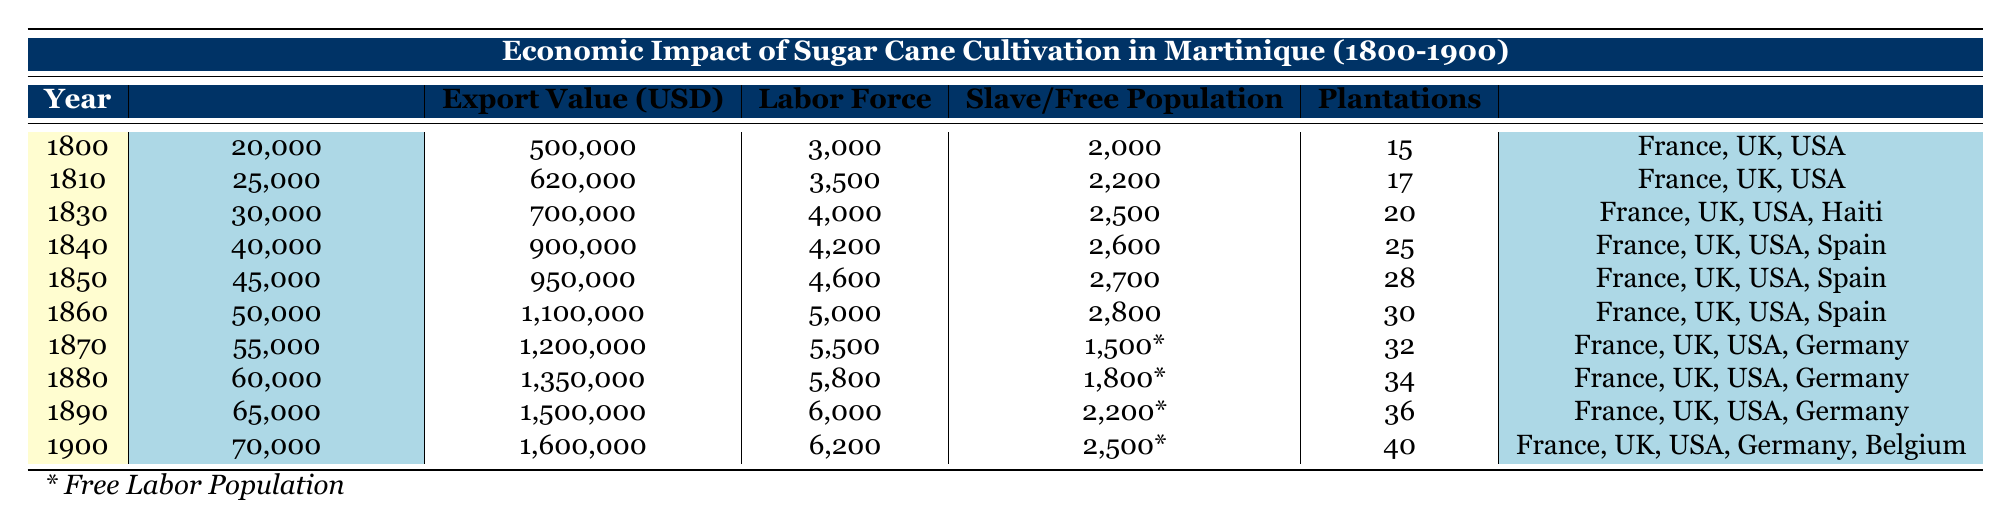What was the sugar cane production in 1860? According to the table, the sugar cane production in 1860 is listed as 50,000 tons.
Answer: 50,000 tons How many plantations were there in 1890? In the table, the number of plantations in 1890 is recorded as 36.
Answer: 36 What is the total export value of sugar cane from 1800 to 1900? To find the total export value, we add the export values for each year: 500,000 + 620,000 + 700,000 + 900,000 + 950,000 + 1,100,000 + 1,200,000 + 1,350,000 + 1,500,000 + 1,600,000 = 10,120,000.
Answer: 10,120,000 USD Was there an increase in the Labor Force from 1810 to 1870? By comparing the Labor Force figures, in 1810 it was 3,500 and in 1870 it was 5,500. This indicates an increase over that period.
Answer: Yes What was the average sugar cane production from 1850 to 1900? To calculate the average production from 1850 to 1900, we take the total sugar cane production for those years: (45,000 + 50,000 + 55,000 + 60,000 + 65,000 + 70,000) = 350,000 tons, then divide by the number of years (6): 350,000 / 6 = 58,333.33.
Answer: 58,333.33 tons In which year was the Slave Population highest? Looking at the Slave Population column, the highest number recorded is 2,800 in 1860.
Answer: 1860 How did the export value change from 1800 to 1900? The export value in 1800 was 500,000 USD and in 1900 it was 1,600,000 USD. This suggests a significant increase over the century. The difference is 1,600,000 - 500,000 = 1,100,000.
Answer: Increased by 1,100,000 USD What percentage of the labor force in 1880 was free labor? In 1880, the labor force was 5,800, and the free labor population is noted as 1,800. To find the percentage, we calculate (1,800 / 5,800) * 100 = 31.03%.
Answer: 31.03% 